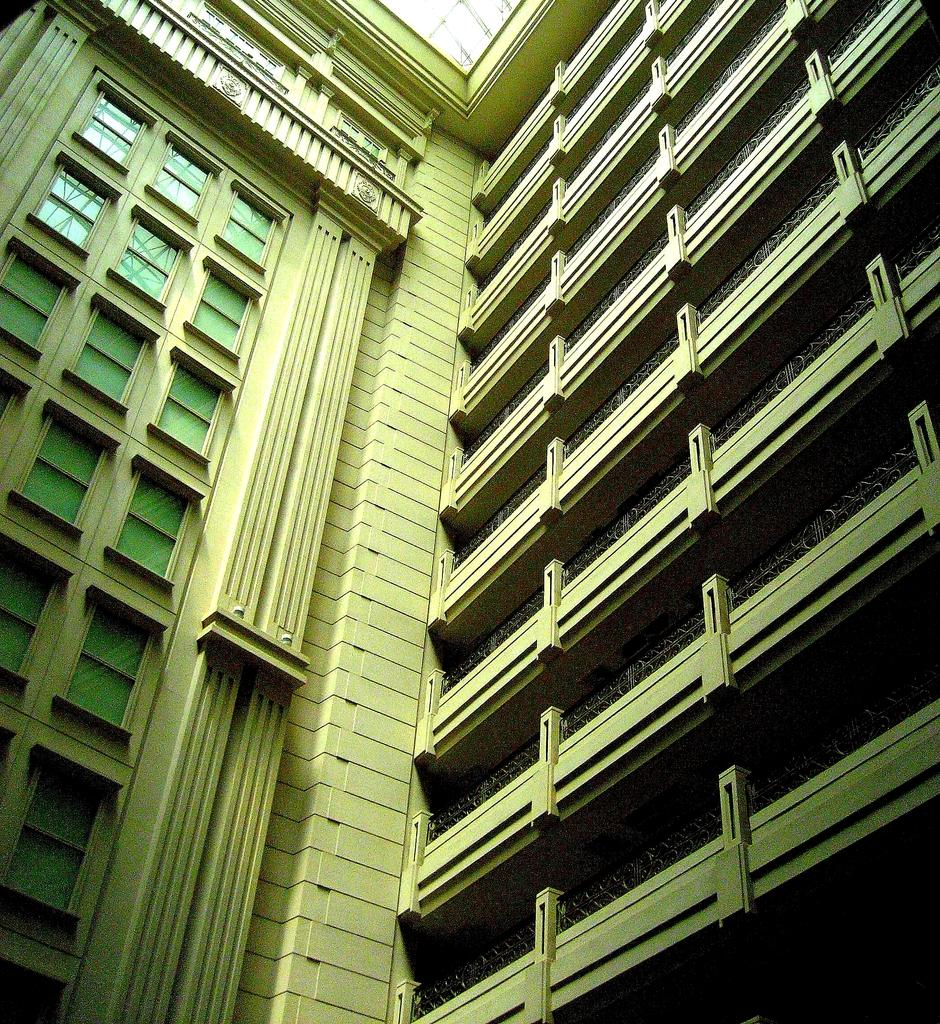How many buildings can be seen in the image? There are two buildings in the image. What is a notable feature of the buildings? The buildings have many glass windows. What type of calculator is being used by the person standing in front of the buildings? There is no person or calculator present in the image. What is the frame made of that surrounds the buildings? The image does not provide information about a frame surrounding the buildings. 